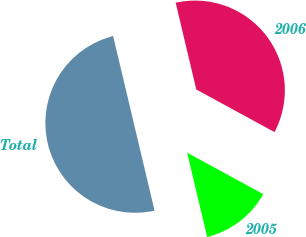<chart> <loc_0><loc_0><loc_500><loc_500><pie_chart><fcel>2005<fcel>2006<fcel>Total<nl><fcel>13.35%<fcel>36.65%<fcel>50.0%<nl></chart> 